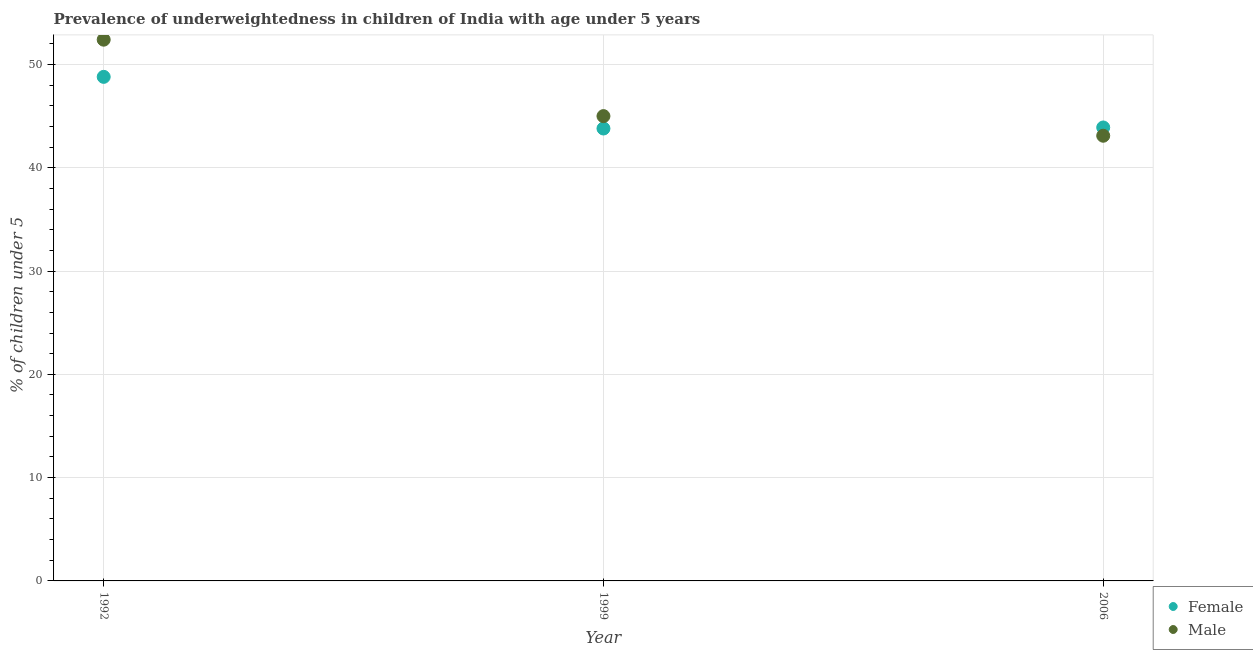How many different coloured dotlines are there?
Make the answer very short. 2. What is the percentage of underweighted female children in 2006?
Your answer should be very brief. 43.9. Across all years, what is the maximum percentage of underweighted female children?
Offer a very short reply. 48.8. Across all years, what is the minimum percentage of underweighted male children?
Ensure brevity in your answer.  43.1. In which year was the percentage of underweighted male children maximum?
Your answer should be very brief. 1992. In which year was the percentage of underweighted male children minimum?
Your response must be concise. 2006. What is the total percentage of underweighted male children in the graph?
Your answer should be compact. 140.5. What is the difference between the percentage of underweighted male children in 1992 and that in 1999?
Provide a short and direct response. 7.4. What is the difference between the percentage of underweighted male children in 2006 and the percentage of underweighted female children in 1992?
Your answer should be very brief. -5.7. What is the average percentage of underweighted male children per year?
Make the answer very short. 46.83. In the year 2006, what is the difference between the percentage of underweighted male children and percentage of underweighted female children?
Your answer should be very brief. -0.8. In how many years, is the percentage of underweighted female children greater than 42 %?
Offer a very short reply. 3. What is the ratio of the percentage of underweighted male children in 1992 to that in 1999?
Keep it short and to the point. 1.16. Is the difference between the percentage of underweighted female children in 1999 and 2006 greater than the difference between the percentage of underweighted male children in 1999 and 2006?
Keep it short and to the point. No. What is the difference between the highest and the second highest percentage of underweighted male children?
Provide a short and direct response. 7.4. What is the difference between the highest and the lowest percentage of underweighted male children?
Provide a short and direct response. 9.3. In how many years, is the percentage of underweighted male children greater than the average percentage of underweighted male children taken over all years?
Provide a short and direct response. 1. Is the sum of the percentage of underweighted male children in 1999 and 2006 greater than the maximum percentage of underweighted female children across all years?
Provide a short and direct response. Yes. Does the percentage of underweighted male children monotonically increase over the years?
Your answer should be compact. No. Is the percentage of underweighted male children strictly less than the percentage of underweighted female children over the years?
Offer a very short reply. No. How many dotlines are there?
Make the answer very short. 2. How many years are there in the graph?
Keep it short and to the point. 3. What is the difference between two consecutive major ticks on the Y-axis?
Your answer should be very brief. 10. What is the title of the graph?
Your answer should be compact. Prevalence of underweightedness in children of India with age under 5 years. What is the label or title of the X-axis?
Give a very brief answer. Year. What is the label or title of the Y-axis?
Provide a short and direct response.  % of children under 5. What is the  % of children under 5 of Female in 1992?
Keep it short and to the point. 48.8. What is the  % of children under 5 of Male in 1992?
Offer a terse response. 52.4. What is the  % of children under 5 of Female in 1999?
Your response must be concise. 43.8. What is the  % of children under 5 in Female in 2006?
Provide a short and direct response. 43.9. What is the  % of children under 5 of Male in 2006?
Make the answer very short. 43.1. Across all years, what is the maximum  % of children under 5 in Female?
Offer a very short reply. 48.8. Across all years, what is the maximum  % of children under 5 of Male?
Give a very brief answer. 52.4. Across all years, what is the minimum  % of children under 5 of Female?
Your response must be concise. 43.8. Across all years, what is the minimum  % of children under 5 of Male?
Your answer should be very brief. 43.1. What is the total  % of children under 5 in Female in the graph?
Your response must be concise. 136.5. What is the total  % of children under 5 in Male in the graph?
Provide a short and direct response. 140.5. What is the difference between the  % of children under 5 in Female in 1992 and that in 1999?
Provide a short and direct response. 5. What is the difference between the  % of children under 5 in Male in 1992 and that in 1999?
Keep it short and to the point. 7.4. What is the difference between the  % of children under 5 in Female in 1992 and that in 2006?
Provide a short and direct response. 4.9. What is the difference between the  % of children under 5 in Male in 1992 and that in 2006?
Provide a short and direct response. 9.3. What is the difference between the  % of children under 5 in Male in 1999 and that in 2006?
Give a very brief answer. 1.9. What is the average  % of children under 5 in Female per year?
Your answer should be very brief. 45.5. What is the average  % of children under 5 of Male per year?
Your answer should be compact. 46.83. In the year 1992, what is the difference between the  % of children under 5 in Female and  % of children under 5 in Male?
Your answer should be compact. -3.6. In the year 1999, what is the difference between the  % of children under 5 of Female and  % of children under 5 of Male?
Your answer should be compact. -1.2. In the year 2006, what is the difference between the  % of children under 5 of Female and  % of children under 5 of Male?
Your answer should be compact. 0.8. What is the ratio of the  % of children under 5 in Female in 1992 to that in 1999?
Your response must be concise. 1.11. What is the ratio of the  % of children under 5 of Male in 1992 to that in 1999?
Provide a short and direct response. 1.16. What is the ratio of the  % of children under 5 of Female in 1992 to that in 2006?
Give a very brief answer. 1.11. What is the ratio of the  % of children under 5 of Male in 1992 to that in 2006?
Your answer should be very brief. 1.22. What is the ratio of the  % of children under 5 of Male in 1999 to that in 2006?
Ensure brevity in your answer.  1.04. What is the difference between the highest and the second highest  % of children under 5 of Male?
Provide a short and direct response. 7.4. What is the difference between the highest and the lowest  % of children under 5 in Female?
Make the answer very short. 5. What is the difference between the highest and the lowest  % of children under 5 of Male?
Your response must be concise. 9.3. 